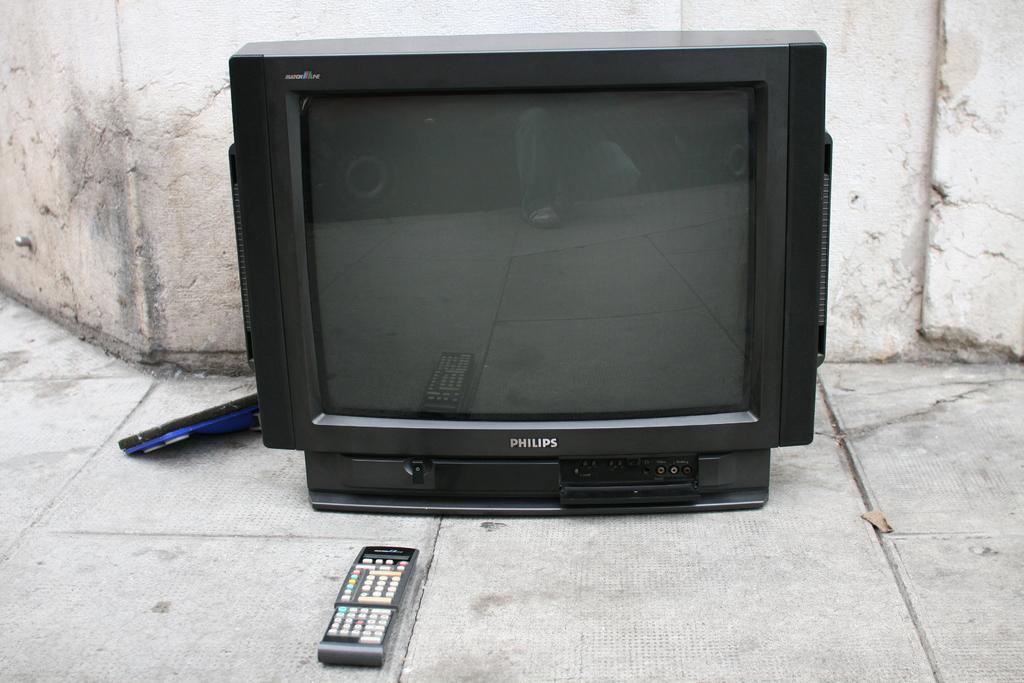What is the make of that tv set?
Your answer should be compact. Philips. 